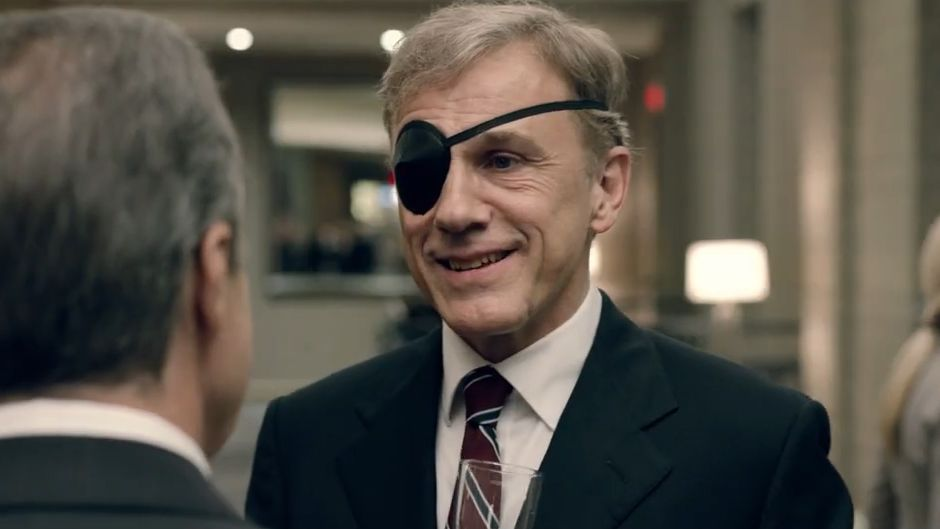Write a detailed description of the given image. In this image, the renowned actor Christoph Waltz is captured in a moment of engaging conversation. Dressed immaculately in a dark suit paired with a neatly knotted tie, he exudes an air of sophistication and charisma. A distinct and intriguing element of his appearance is the black eye patch he wears over his left eye, adding a layer of mystery to his demeanor. Christoph is positioned slightly to the right side of the frame, turning to his left to interact with another individual who is partially visible in the foreground. Waltz's expression is one of amusement, a warm and genuine smile lighting up his face. The background, suggesting an office or a luxurious lobby, is tastefully blurred, ensuring that Waltz remains the central focus of the image. 